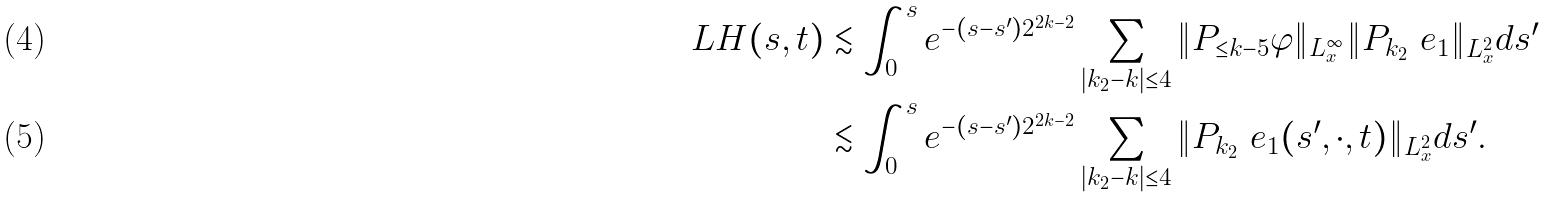Convert formula to latex. <formula><loc_0><loc_0><loc_500><loc_500>L H ( s , t ) & \lesssim \int _ { 0 } ^ { s } e ^ { - ( s - s ^ { \prime } ) 2 ^ { 2 k - 2 } } \sum _ { | k _ { 2 } - k | \leq 4 } \| P _ { \leq k - 5 } \varphi \| _ { L _ { x } ^ { \infty } } \| P _ { k _ { 2 } } \ e _ { 1 } \| _ { L _ { x } ^ { 2 } } d s ^ { \prime } \\ & \lesssim \int _ { 0 } ^ { s } e ^ { - ( s - s ^ { \prime } ) 2 ^ { 2 k - 2 } } \sum _ { | k _ { 2 } - k | \leq 4 } \| P _ { k _ { 2 } } \ e _ { 1 } ( s ^ { \prime } , \cdot , t ) \| _ { L _ { x } ^ { 2 } } d s ^ { \prime } .</formula> 